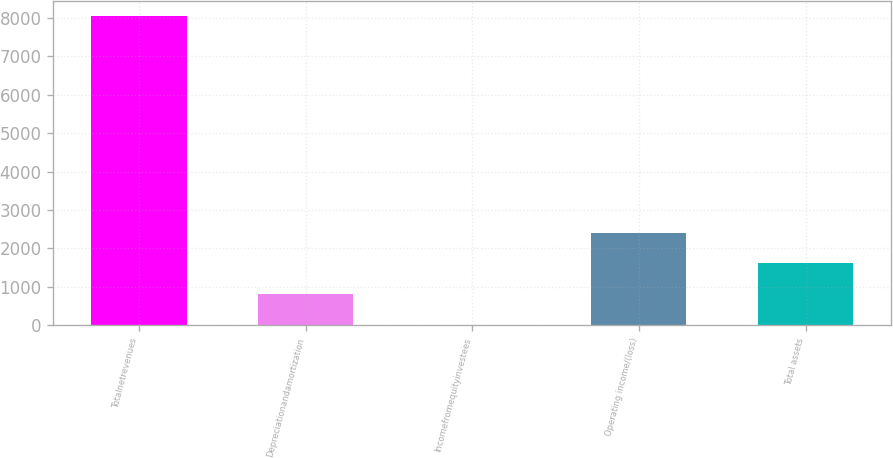Convert chart to OTSL. <chart><loc_0><loc_0><loc_500><loc_500><bar_chart><fcel>Totalnetrevenues<fcel>Depreciationandamortization<fcel>Incomefromequityinvestees<fcel>Operating income/(loss)<fcel>Total assets<nl><fcel>8038<fcel>805.47<fcel>1.85<fcel>2412.7<fcel>1609.09<nl></chart> 